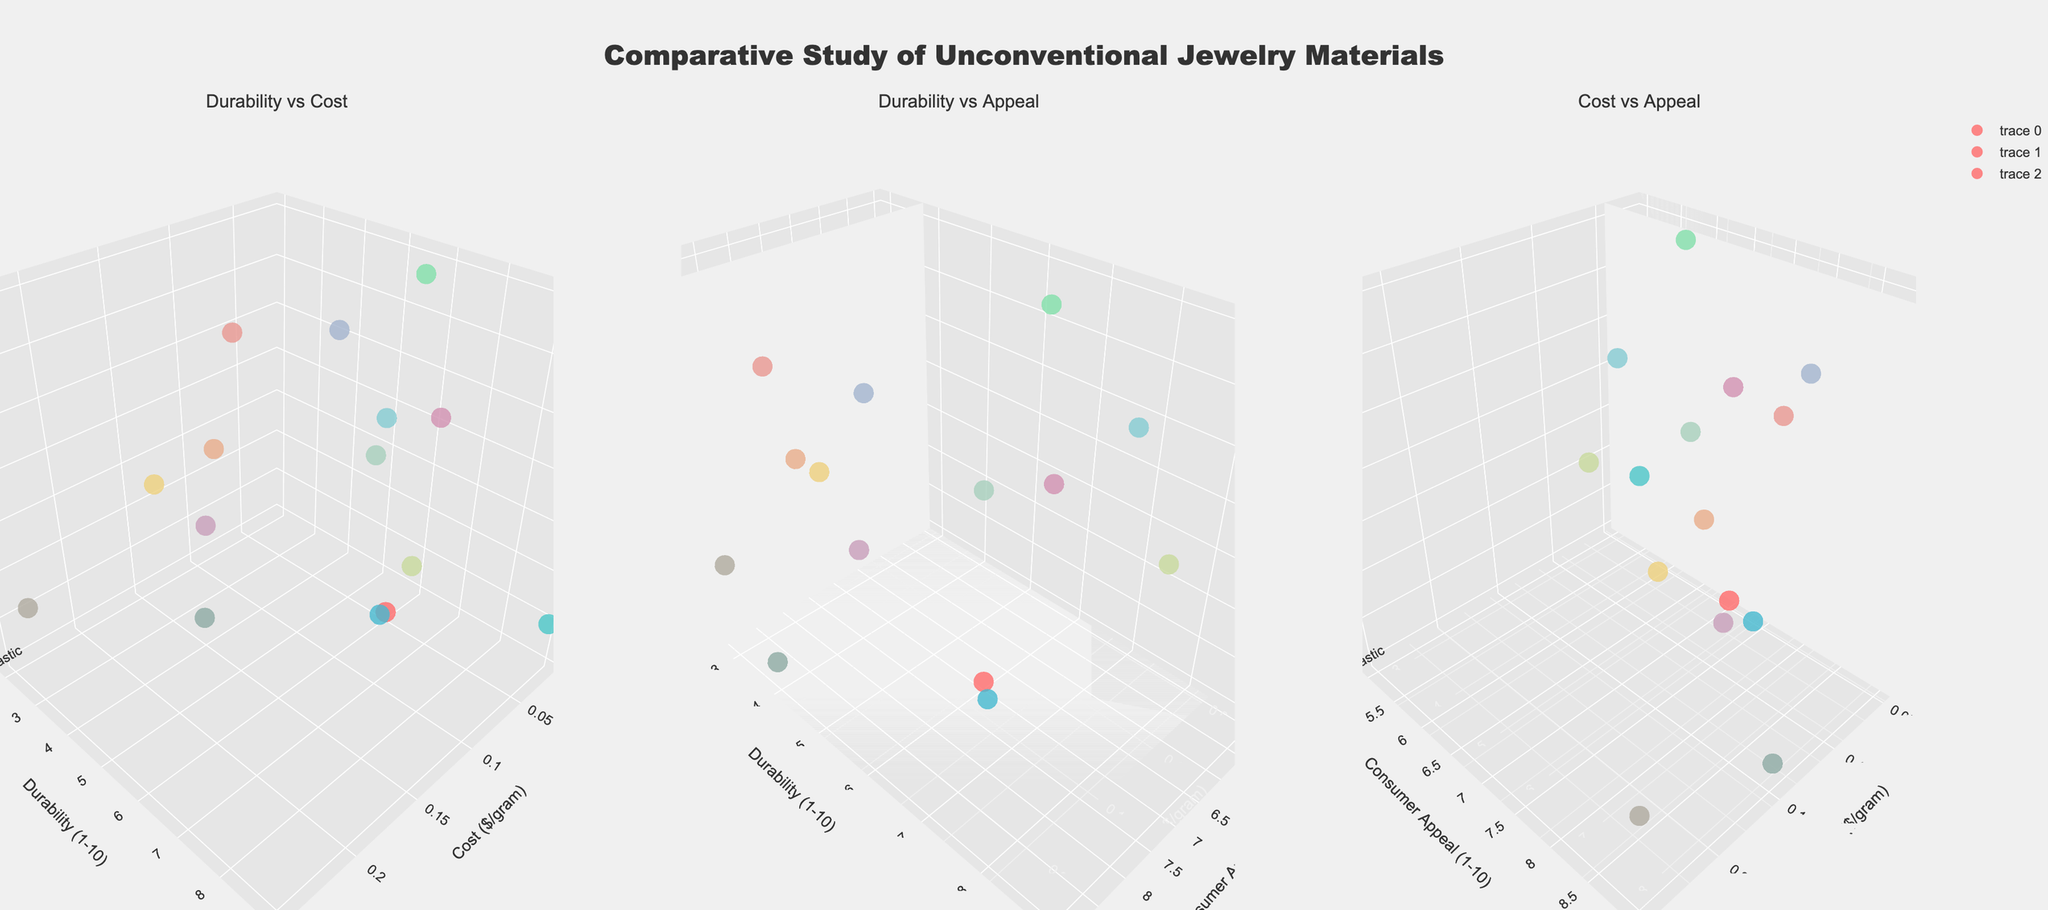What is the title of the figure? The title is located at the top of the figure and provides an overview of what is being shown. It reads "Comparative Study of Unconventional Jewelry Materials."
Answer: Comparative Study of Unconventional Jewelry Materials What are the axes labels for the first subplot? In the first subplot, the x-axis is labeled "Cost ($/gram)", the y-axis is labeled "Durability (1-10)", and the z-axis is labeled "Material."
Answer: Cost ($/gram), Durability (1-10), Material How many materials have a durability rating of 7 or higher? By examining the durability axis (y-axis) in the subplots focused on durability against other metrics, we see Recycled Circuit Boards (7), Broken Glass (7), Lava Rock (8), and Copper Wire (8), and Concrete (9). Additionally, Recycled Plastic and Glow-in-the-Dark Resin each have durability ratings of 6.
Answer: 5 materials Which material has the lowest consumer appeal? By looking at the axis labeled "Consumer Appeal (1-10)," we see that materials such as Concrete, Candy Wrappers, and Seashells have the lowest ratings around 5 and 6.
Answer: Concrete Between Recycled Plastic and Neon Tubes, which one is more cost-effective? Examining the cost axis for these two materials, we see Recycled Plastic has a cost of $0.05/gram while Neon Tubes have a higher cost of $0.25/gram.
Answer: Recycled Plastic Which subplots compare the durability against other metrics? By reading the subplot titles, it is clear that the first and the second subplots compare "Durability vs Cost" and "Durability vs Appeal," respectively.
Answer: First and Second subplots Among the materials with a consumer appeal rating of at least 8, which one has the highest durability? Looking at the subplot "Durability vs Appeal," the materials with a consumer appeal of at least 8 include Beetle Wings, Recycled Circuit Boards, Neon Tubes, Holographic Film, Glow-in-the-Dark Resin, Dried Flowers, and Recycled Vinyl Records. Among these, Recycled Circuit Boards have the highest durability of 7.
Answer: Recycled Circuit Boards Which material is the most durable yet relatively cost-effective (below $0.1/gram)? In the "Durability vs Cost" subplot, Concrete ($0.02/gram) and Recycled Circuit Boards ($0.1/gram) have high durability ratings, with Concrete being the most durable.
Answer: Concrete What is the common feature of the materials positioned at the top right corner of the "Cost vs Appeal" subplot? The top right corner indicates high cost and high consumer appeal. Materials like Neon Tubes, Holographic Film, and Glow-in-the-Dark Resin are positioned here, signifying they are both expensive and highly appealing.
Answer: High cost and high appeal 